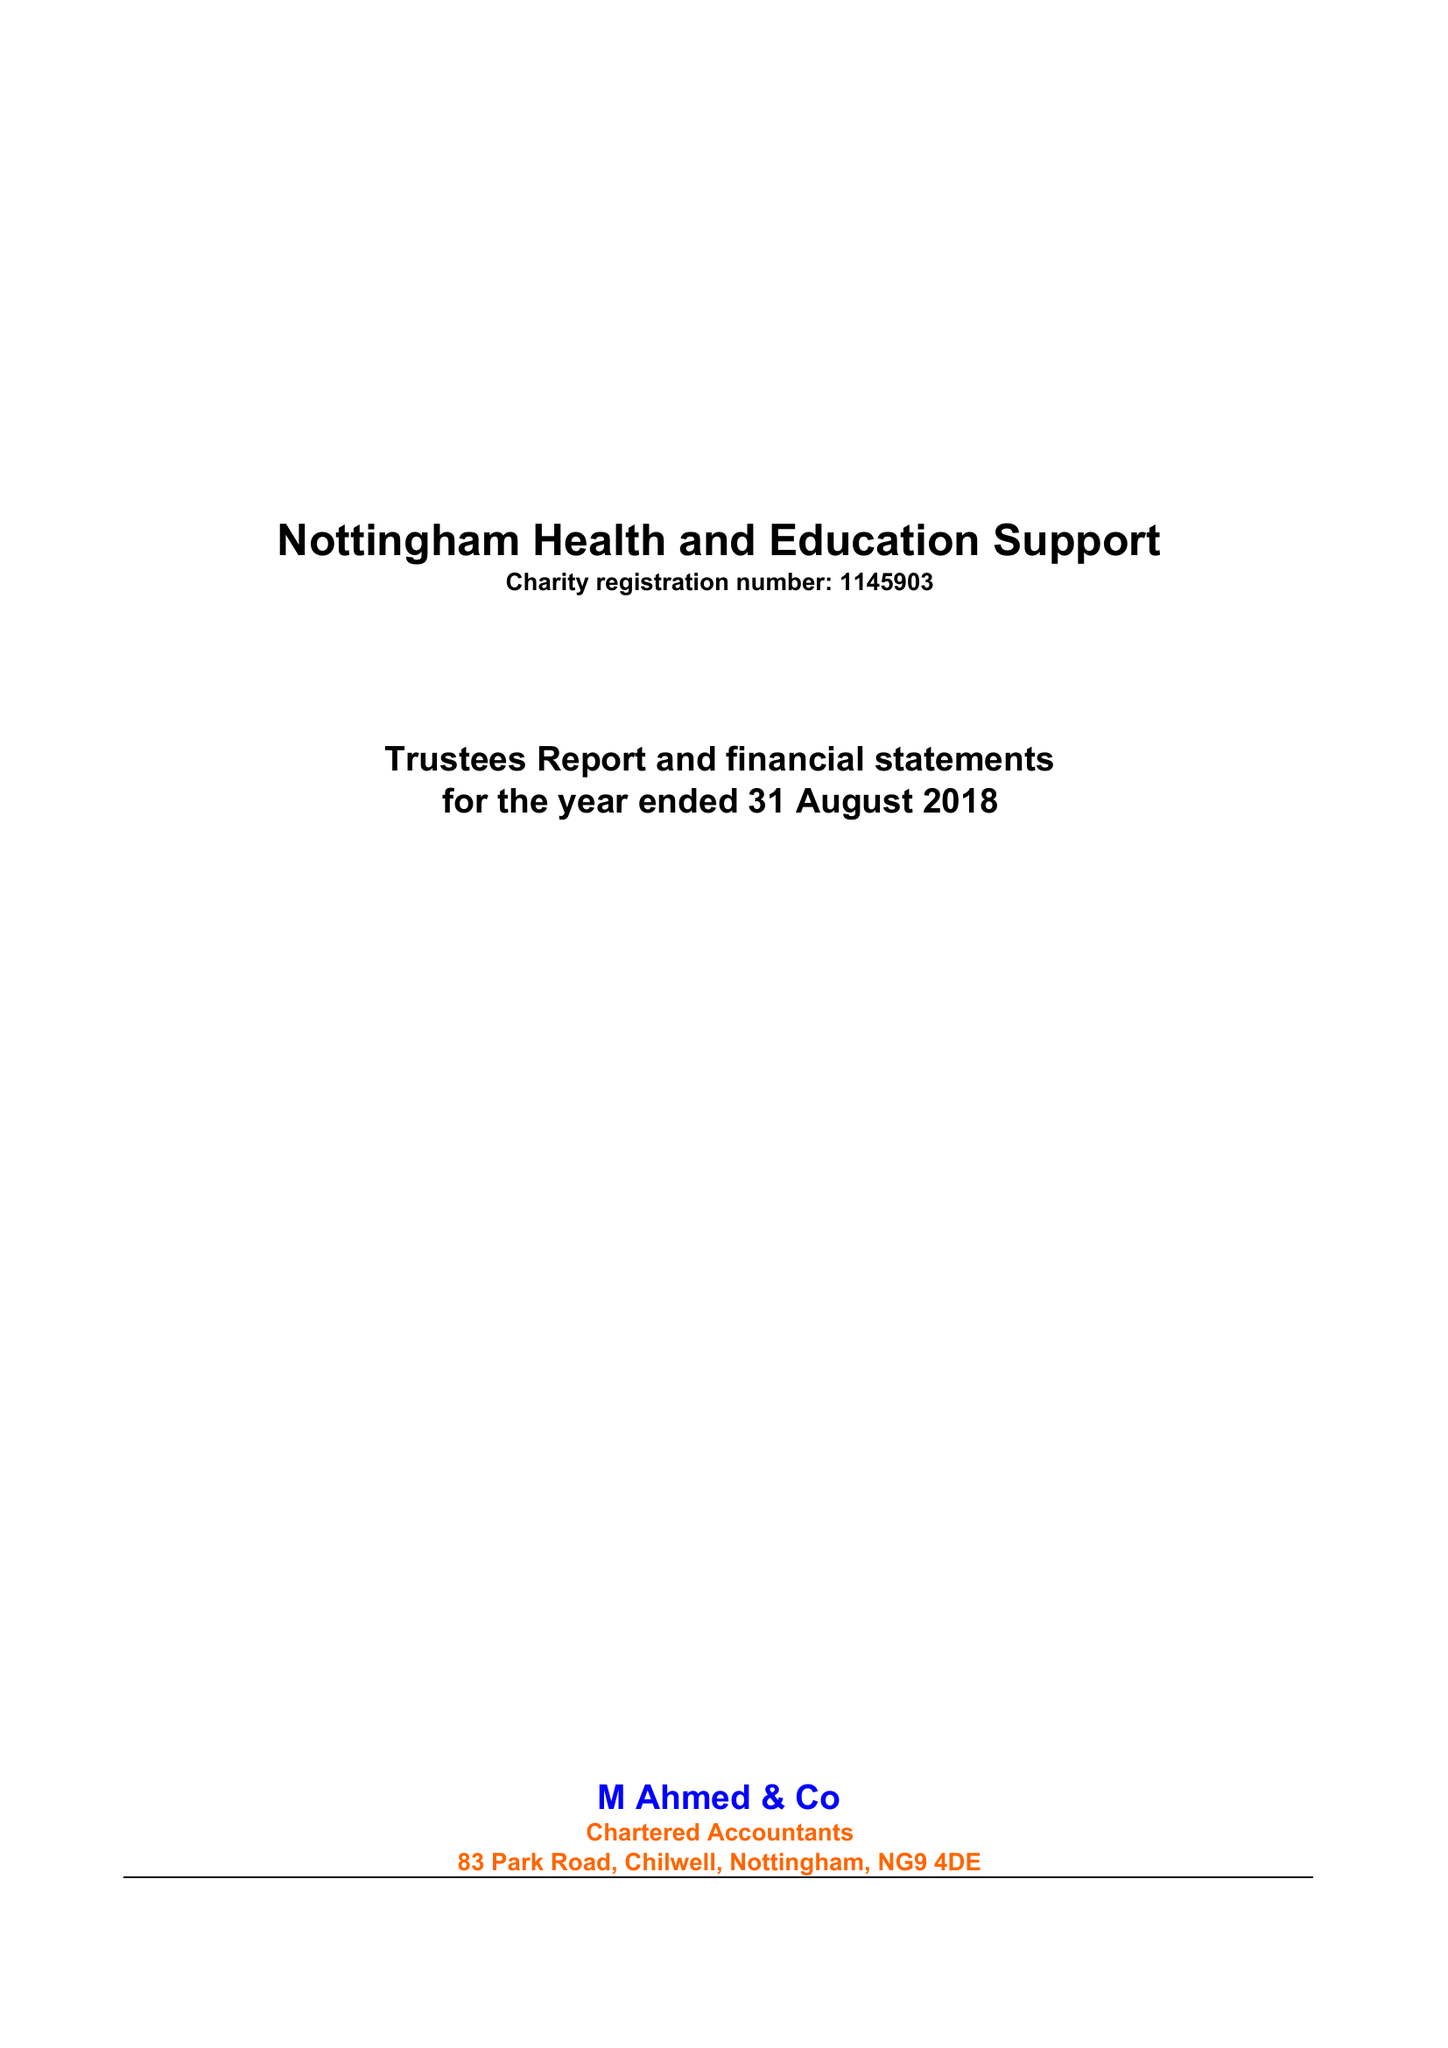What is the value for the charity_name?
Answer the question using a single word or phrase. Nottingham Health and Education Support 